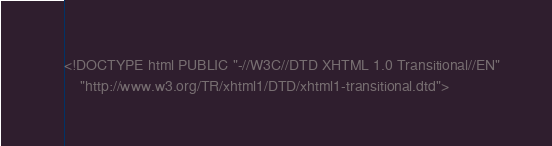<code> <loc_0><loc_0><loc_500><loc_500><_HTML_><!DOCTYPE html PUBLIC "-//W3C//DTD XHTML 1.0 Transitional//EN"
    "http://www.w3.org/TR/xhtml1/DTD/xhtml1-transitional.dtd">
</code> 